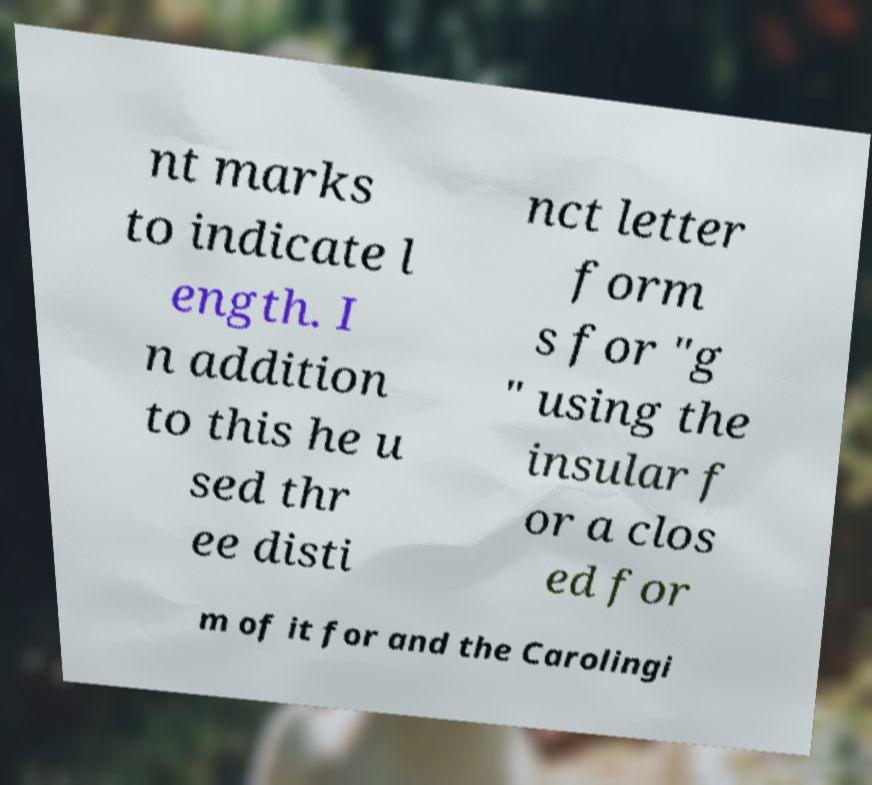I need the written content from this picture converted into text. Can you do that? nt marks to indicate l ength. I n addition to this he u sed thr ee disti nct letter form s for "g " using the insular f or a clos ed for m of it for and the Carolingi 